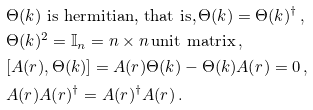<formula> <loc_0><loc_0><loc_500><loc_500>& \Theta ( k ) \text { is hermitian, that is,} \, \Theta ( k ) = \Theta ( k ) ^ { \dagger } \, , \\ & \Theta ( k ) ^ { 2 } = \mathbb { I } _ { n } = n \times n \, \text {unit matrix} \, , \\ & [ A ( r ) , \Theta ( k ) ] = A ( r ) \Theta ( k ) - \Theta ( k ) A ( r ) = 0 \, , \\ & A ( r ) A ( r ) ^ { \dagger } = A ( r ) ^ { \dagger } A ( r ) \, .</formula> 